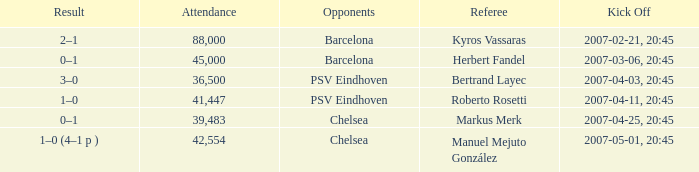WHAT OPPONENT HAD A KICKOFF OF 2007-03-06, 20:45? Barcelona. 